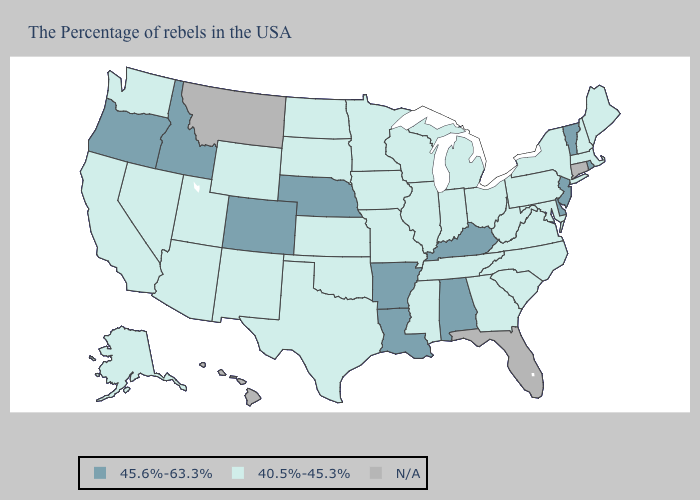What is the lowest value in states that border Tennessee?
Short answer required. 40.5%-45.3%. What is the value of Indiana?
Quick response, please. 40.5%-45.3%. Name the states that have a value in the range 45.6%-63.3%?
Give a very brief answer. Rhode Island, Vermont, New Jersey, Delaware, Kentucky, Alabama, Louisiana, Arkansas, Nebraska, Colorado, Idaho, Oregon. Does Idaho have the lowest value in the USA?
Quick response, please. No. Among the states that border Delaware , which have the highest value?
Short answer required. New Jersey. What is the value of Ohio?
Concise answer only. 40.5%-45.3%. What is the value of Vermont?
Give a very brief answer. 45.6%-63.3%. Does the first symbol in the legend represent the smallest category?
Quick response, please. No. Does Louisiana have the highest value in the USA?
Be succinct. Yes. Name the states that have a value in the range 45.6%-63.3%?
Be succinct. Rhode Island, Vermont, New Jersey, Delaware, Kentucky, Alabama, Louisiana, Arkansas, Nebraska, Colorado, Idaho, Oregon. Which states have the lowest value in the West?
Quick response, please. Wyoming, New Mexico, Utah, Arizona, Nevada, California, Washington, Alaska. Does Virginia have the lowest value in the South?
Be succinct. Yes. What is the value of South Carolina?
Concise answer only. 40.5%-45.3%. What is the value of Tennessee?
Be succinct. 40.5%-45.3%. 